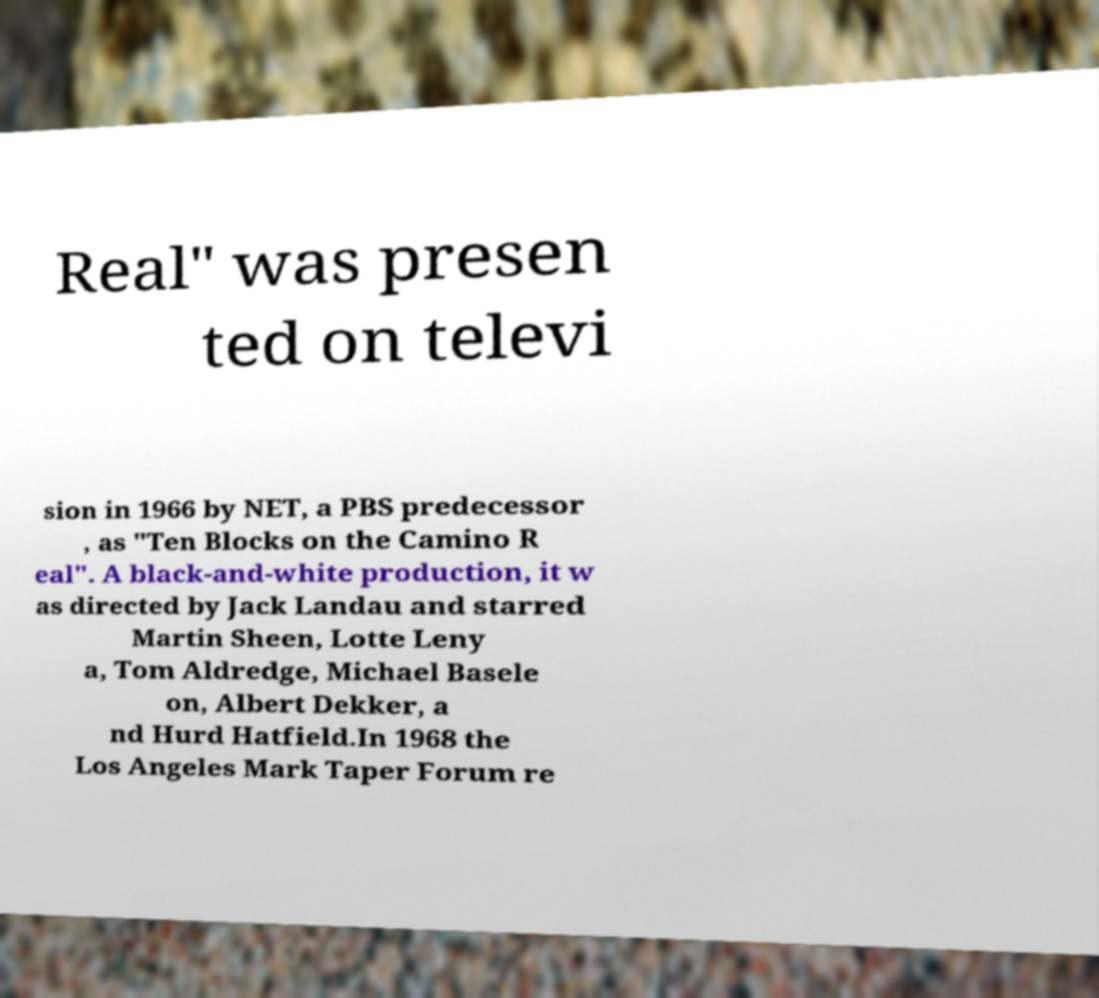I need the written content from this picture converted into text. Can you do that? Real" was presen ted on televi sion in 1966 by NET, a PBS predecessor , as "Ten Blocks on the Camino R eal". A black-and-white production, it w as directed by Jack Landau and starred Martin Sheen, Lotte Leny a, Tom Aldredge, Michael Basele on, Albert Dekker, a nd Hurd Hatfield.In 1968 the Los Angeles Mark Taper Forum re 